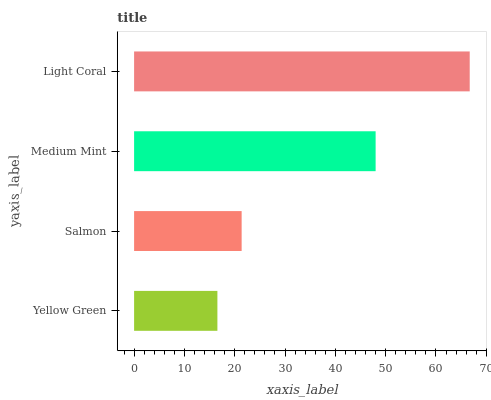Is Yellow Green the minimum?
Answer yes or no. Yes. Is Light Coral the maximum?
Answer yes or no. Yes. Is Salmon the minimum?
Answer yes or no. No. Is Salmon the maximum?
Answer yes or no. No. Is Salmon greater than Yellow Green?
Answer yes or no. Yes. Is Yellow Green less than Salmon?
Answer yes or no. Yes. Is Yellow Green greater than Salmon?
Answer yes or no. No. Is Salmon less than Yellow Green?
Answer yes or no. No. Is Medium Mint the high median?
Answer yes or no. Yes. Is Salmon the low median?
Answer yes or no. Yes. Is Salmon the high median?
Answer yes or no. No. Is Yellow Green the low median?
Answer yes or no. No. 